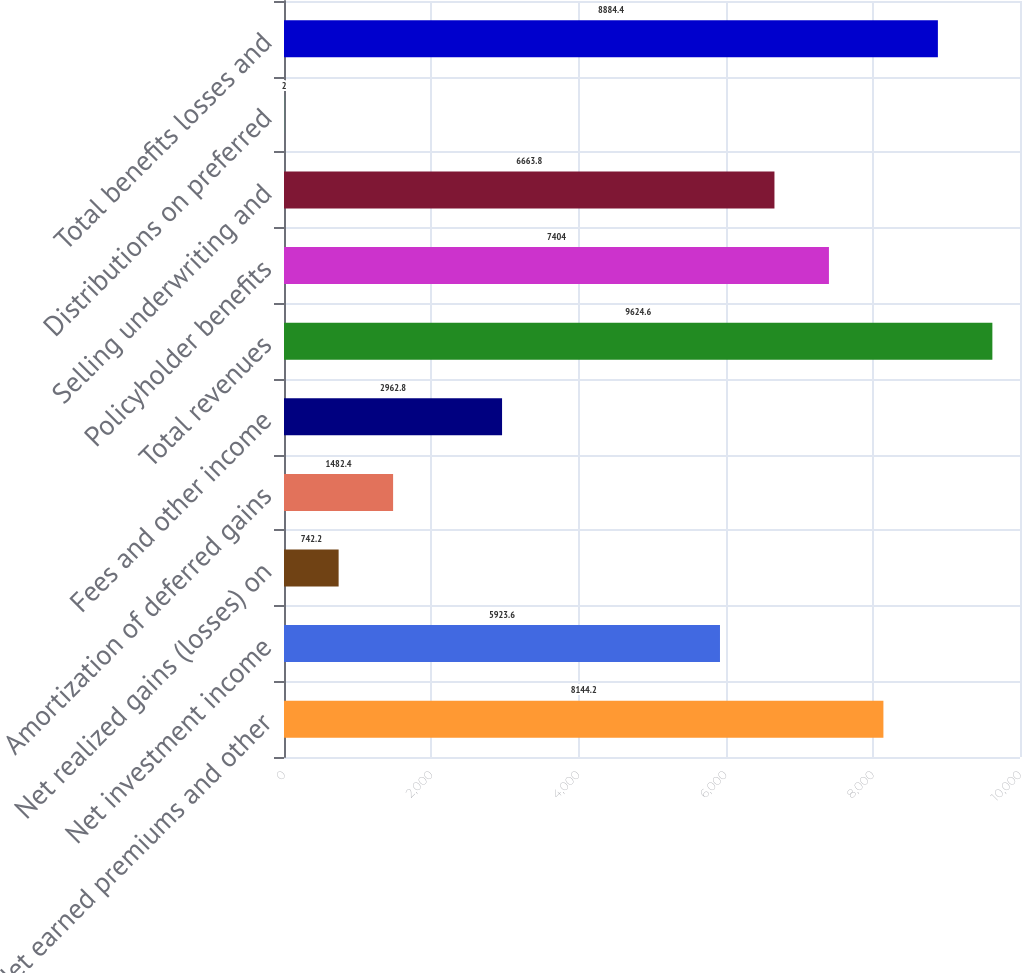<chart> <loc_0><loc_0><loc_500><loc_500><bar_chart><fcel>Net earned premiums and other<fcel>Net investment income<fcel>Net realized gains (losses) on<fcel>Amortization of deferred gains<fcel>Fees and other income<fcel>Total revenues<fcel>Policyholder benefits<fcel>Selling underwriting and<fcel>Distributions on preferred<fcel>Total benefits losses and<nl><fcel>8144.2<fcel>5923.6<fcel>742.2<fcel>1482.4<fcel>2962.8<fcel>9624.6<fcel>7404<fcel>6663.8<fcel>2<fcel>8884.4<nl></chart> 